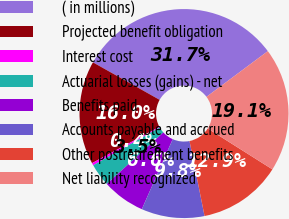Convert chart to OTSL. <chart><loc_0><loc_0><loc_500><loc_500><pie_chart><fcel>( in millions)<fcel>Projected benefit obligation<fcel>Interest cost<fcel>Actuarial losses (gains) - net<fcel>Benefits paid<fcel>Accounts payable and accrued<fcel>Other postretirement benefits<fcel>Net liability recognized<nl><fcel>31.66%<fcel>16.02%<fcel>0.38%<fcel>3.51%<fcel>6.63%<fcel>9.76%<fcel>12.89%<fcel>19.15%<nl></chart> 